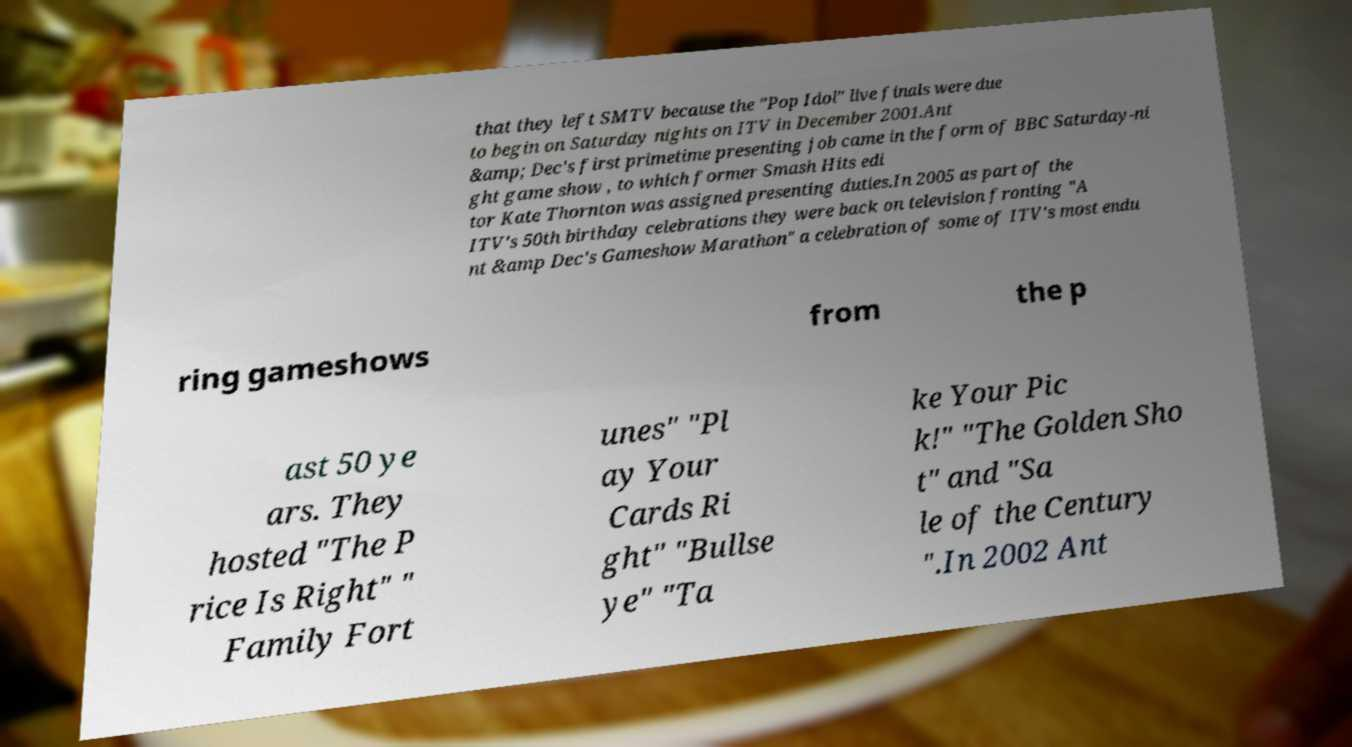There's text embedded in this image that I need extracted. Can you transcribe it verbatim? that they left SMTV because the "Pop Idol" live finals were due to begin on Saturday nights on ITV in December 2001.Ant &amp; Dec's first primetime presenting job came in the form of BBC Saturday-ni ght game show , to which former Smash Hits edi tor Kate Thornton was assigned presenting duties.In 2005 as part of the ITV's 50th birthday celebrations they were back on television fronting "A nt &amp Dec's Gameshow Marathon" a celebration of some of ITV's most endu ring gameshows from the p ast 50 ye ars. They hosted "The P rice Is Right" " Family Fort unes" "Pl ay Your Cards Ri ght" "Bullse ye" "Ta ke Your Pic k!" "The Golden Sho t" and "Sa le of the Century ".In 2002 Ant 